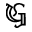Convert formula to latex. <formula><loc_0><loc_0><loc_500><loc_500>\mathfrak { G }</formula> 